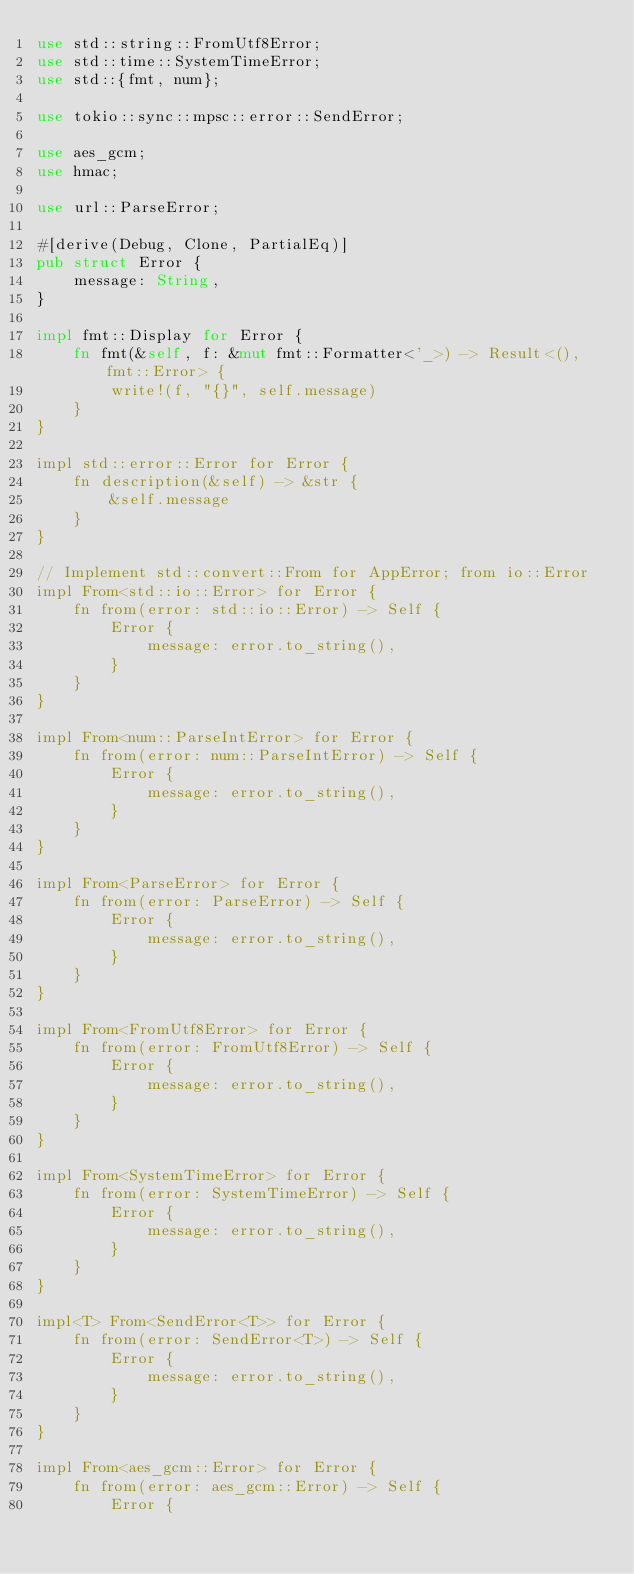<code> <loc_0><loc_0><loc_500><loc_500><_Rust_>use std::string::FromUtf8Error;
use std::time::SystemTimeError;
use std::{fmt, num};

use tokio::sync::mpsc::error::SendError;

use aes_gcm;
use hmac;

use url::ParseError;

#[derive(Debug, Clone, PartialEq)]
pub struct Error {
    message: String,
}

impl fmt::Display for Error {
    fn fmt(&self, f: &mut fmt::Formatter<'_>) -> Result<(), fmt::Error> {
        write!(f, "{}", self.message)
    }
}

impl std::error::Error for Error {
    fn description(&self) -> &str {
        &self.message
    }
}

// Implement std::convert::From for AppError; from io::Error
impl From<std::io::Error> for Error {
    fn from(error: std::io::Error) -> Self {
        Error {
            message: error.to_string(),
        }
    }
}

impl From<num::ParseIntError> for Error {
    fn from(error: num::ParseIntError) -> Self {
        Error {
            message: error.to_string(),
        }
    }
}

impl From<ParseError> for Error {
    fn from(error: ParseError) -> Self {
        Error {
            message: error.to_string(),
        }
    }
}

impl From<FromUtf8Error> for Error {
    fn from(error: FromUtf8Error) -> Self {
        Error {
            message: error.to_string(),
        }
    }
}

impl From<SystemTimeError> for Error {
    fn from(error: SystemTimeError) -> Self {
        Error {
            message: error.to_string(),
        }
    }
}

impl<T> From<SendError<T>> for Error {
    fn from(error: SendError<T>) -> Self {
        Error {
            message: error.to_string(),
        }
    }
}

impl From<aes_gcm::Error> for Error {
    fn from(error: aes_gcm::Error) -> Self {
        Error {</code> 